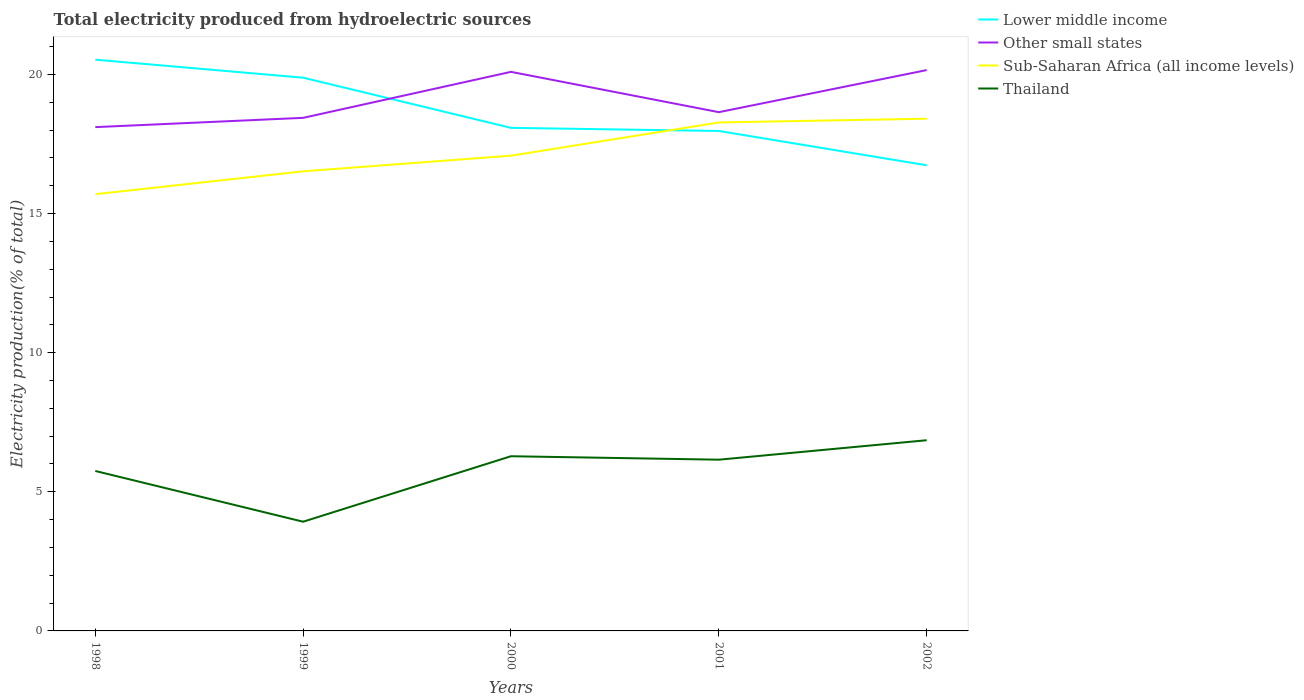How many different coloured lines are there?
Your answer should be very brief. 4. Across all years, what is the maximum total electricity produced in Sub-Saharan Africa (all income levels)?
Ensure brevity in your answer.  15.7. What is the total total electricity produced in Lower middle income in the graph?
Offer a terse response. 2.56. What is the difference between the highest and the second highest total electricity produced in Lower middle income?
Provide a succinct answer. 3.8. How many lines are there?
Keep it short and to the point. 4. What is the difference between two consecutive major ticks on the Y-axis?
Provide a succinct answer. 5. Are the values on the major ticks of Y-axis written in scientific E-notation?
Provide a short and direct response. No. Does the graph contain any zero values?
Give a very brief answer. No. Does the graph contain grids?
Your response must be concise. No. How many legend labels are there?
Keep it short and to the point. 4. What is the title of the graph?
Your answer should be very brief. Total electricity produced from hydroelectric sources. What is the Electricity production(% of total) in Lower middle income in 1998?
Keep it short and to the point. 20.53. What is the Electricity production(% of total) of Other small states in 1998?
Provide a short and direct response. 18.11. What is the Electricity production(% of total) in Sub-Saharan Africa (all income levels) in 1998?
Your response must be concise. 15.7. What is the Electricity production(% of total) of Thailand in 1998?
Keep it short and to the point. 5.75. What is the Electricity production(% of total) of Lower middle income in 1999?
Make the answer very short. 19.88. What is the Electricity production(% of total) of Other small states in 1999?
Offer a very short reply. 18.44. What is the Electricity production(% of total) in Sub-Saharan Africa (all income levels) in 1999?
Offer a very short reply. 16.52. What is the Electricity production(% of total) of Thailand in 1999?
Offer a terse response. 3.92. What is the Electricity production(% of total) in Lower middle income in 2000?
Give a very brief answer. 18.08. What is the Electricity production(% of total) of Other small states in 2000?
Keep it short and to the point. 20.09. What is the Electricity production(% of total) in Sub-Saharan Africa (all income levels) in 2000?
Offer a very short reply. 17.08. What is the Electricity production(% of total) in Thailand in 2000?
Make the answer very short. 6.28. What is the Electricity production(% of total) of Lower middle income in 2001?
Provide a short and direct response. 17.97. What is the Electricity production(% of total) in Other small states in 2001?
Your answer should be compact. 18.64. What is the Electricity production(% of total) of Sub-Saharan Africa (all income levels) in 2001?
Make the answer very short. 18.27. What is the Electricity production(% of total) in Thailand in 2001?
Offer a terse response. 6.15. What is the Electricity production(% of total) in Lower middle income in 2002?
Give a very brief answer. 16.73. What is the Electricity production(% of total) of Other small states in 2002?
Your answer should be very brief. 20.16. What is the Electricity production(% of total) of Sub-Saharan Africa (all income levels) in 2002?
Keep it short and to the point. 18.41. What is the Electricity production(% of total) in Thailand in 2002?
Give a very brief answer. 6.85. Across all years, what is the maximum Electricity production(% of total) in Lower middle income?
Provide a short and direct response. 20.53. Across all years, what is the maximum Electricity production(% of total) of Other small states?
Offer a very short reply. 20.16. Across all years, what is the maximum Electricity production(% of total) in Sub-Saharan Africa (all income levels)?
Make the answer very short. 18.41. Across all years, what is the maximum Electricity production(% of total) of Thailand?
Ensure brevity in your answer.  6.85. Across all years, what is the minimum Electricity production(% of total) in Lower middle income?
Provide a succinct answer. 16.73. Across all years, what is the minimum Electricity production(% of total) in Other small states?
Give a very brief answer. 18.11. Across all years, what is the minimum Electricity production(% of total) of Sub-Saharan Africa (all income levels)?
Provide a short and direct response. 15.7. Across all years, what is the minimum Electricity production(% of total) of Thailand?
Offer a very short reply. 3.92. What is the total Electricity production(% of total) of Lower middle income in the graph?
Ensure brevity in your answer.  93.2. What is the total Electricity production(% of total) of Other small states in the graph?
Make the answer very short. 95.44. What is the total Electricity production(% of total) of Sub-Saharan Africa (all income levels) in the graph?
Ensure brevity in your answer.  85.98. What is the total Electricity production(% of total) in Thailand in the graph?
Your response must be concise. 28.96. What is the difference between the Electricity production(% of total) of Lower middle income in 1998 and that in 1999?
Ensure brevity in your answer.  0.65. What is the difference between the Electricity production(% of total) in Other small states in 1998 and that in 1999?
Your response must be concise. -0.33. What is the difference between the Electricity production(% of total) of Sub-Saharan Africa (all income levels) in 1998 and that in 1999?
Provide a succinct answer. -0.82. What is the difference between the Electricity production(% of total) in Thailand in 1998 and that in 1999?
Your answer should be compact. 1.82. What is the difference between the Electricity production(% of total) in Lower middle income in 1998 and that in 2000?
Offer a terse response. 2.45. What is the difference between the Electricity production(% of total) in Other small states in 1998 and that in 2000?
Ensure brevity in your answer.  -1.99. What is the difference between the Electricity production(% of total) of Sub-Saharan Africa (all income levels) in 1998 and that in 2000?
Offer a terse response. -1.38. What is the difference between the Electricity production(% of total) in Thailand in 1998 and that in 2000?
Make the answer very short. -0.53. What is the difference between the Electricity production(% of total) of Lower middle income in 1998 and that in 2001?
Offer a terse response. 2.56. What is the difference between the Electricity production(% of total) in Other small states in 1998 and that in 2001?
Provide a short and direct response. -0.54. What is the difference between the Electricity production(% of total) of Sub-Saharan Africa (all income levels) in 1998 and that in 2001?
Make the answer very short. -2.58. What is the difference between the Electricity production(% of total) of Thailand in 1998 and that in 2001?
Make the answer very short. -0.41. What is the difference between the Electricity production(% of total) of Lower middle income in 1998 and that in 2002?
Your answer should be compact. 3.8. What is the difference between the Electricity production(% of total) in Other small states in 1998 and that in 2002?
Make the answer very short. -2.05. What is the difference between the Electricity production(% of total) in Sub-Saharan Africa (all income levels) in 1998 and that in 2002?
Make the answer very short. -2.71. What is the difference between the Electricity production(% of total) of Thailand in 1998 and that in 2002?
Your answer should be compact. -1.1. What is the difference between the Electricity production(% of total) in Lower middle income in 1999 and that in 2000?
Your answer should be compact. 1.8. What is the difference between the Electricity production(% of total) of Other small states in 1999 and that in 2000?
Offer a very short reply. -1.65. What is the difference between the Electricity production(% of total) of Sub-Saharan Africa (all income levels) in 1999 and that in 2000?
Ensure brevity in your answer.  -0.56. What is the difference between the Electricity production(% of total) in Thailand in 1999 and that in 2000?
Keep it short and to the point. -2.35. What is the difference between the Electricity production(% of total) in Lower middle income in 1999 and that in 2001?
Give a very brief answer. 1.91. What is the difference between the Electricity production(% of total) of Other small states in 1999 and that in 2001?
Give a very brief answer. -0.2. What is the difference between the Electricity production(% of total) of Sub-Saharan Africa (all income levels) in 1999 and that in 2001?
Offer a terse response. -1.76. What is the difference between the Electricity production(% of total) in Thailand in 1999 and that in 2001?
Provide a short and direct response. -2.23. What is the difference between the Electricity production(% of total) of Lower middle income in 1999 and that in 2002?
Ensure brevity in your answer.  3.15. What is the difference between the Electricity production(% of total) of Other small states in 1999 and that in 2002?
Give a very brief answer. -1.72. What is the difference between the Electricity production(% of total) in Sub-Saharan Africa (all income levels) in 1999 and that in 2002?
Keep it short and to the point. -1.89. What is the difference between the Electricity production(% of total) of Thailand in 1999 and that in 2002?
Keep it short and to the point. -2.93. What is the difference between the Electricity production(% of total) in Lower middle income in 2000 and that in 2001?
Offer a terse response. 0.11. What is the difference between the Electricity production(% of total) in Other small states in 2000 and that in 2001?
Keep it short and to the point. 1.45. What is the difference between the Electricity production(% of total) in Sub-Saharan Africa (all income levels) in 2000 and that in 2001?
Your response must be concise. -1.19. What is the difference between the Electricity production(% of total) of Thailand in 2000 and that in 2001?
Offer a very short reply. 0.12. What is the difference between the Electricity production(% of total) in Lower middle income in 2000 and that in 2002?
Give a very brief answer. 1.35. What is the difference between the Electricity production(% of total) in Other small states in 2000 and that in 2002?
Your answer should be very brief. -0.06. What is the difference between the Electricity production(% of total) in Sub-Saharan Africa (all income levels) in 2000 and that in 2002?
Offer a terse response. -1.33. What is the difference between the Electricity production(% of total) in Thailand in 2000 and that in 2002?
Offer a terse response. -0.57. What is the difference between the Electricity production(% of total) of Lower middle income in 2001 and that in 2002?
Your response must be concise. 1.23. What is the difference between the Electricity production(% of total) of Other small states in 2001 and that in 2002?
Provide a succinct answer. -1.51. What is the difference between the Electricity production(% of total) in Sub-Saharan Africa (all income levels) in 2001 and that in 2002?
Provide a short and direct response. -0.13. What is the difference between the Electricity production(% of total) in Thailand in 2001 and that in 2002?
Provide a succinct answer. -0.7. What is the difference between the Electricity production(% of total) in Lower middle income in 1998 and the Electricity production(% of total) in Other small states in 1999?
Your answer should be compact. 2.09. What is the difference between the Electricity production(% of total) in Lower middle income in 1998 and the Electricity production(% of total) in Sub-Saharan Africa (all income levels) in 1999?
Keep it short and to the point. 4.01. What is the difference between the Electricity production(% of total) in Lower middle income in 1998 and the Electricity production(% of total) in Thailand in 1999?
Give a very brief answer. 16.61. What is the difference between the Electricity production(% of total) in Other small states in 1998 and the Electricity production(% of total) in Sub-Saharan Africa (all income levels) in 1999?
Provide a succinct answer. 1.59. What is the difference between the Electricity production(% of total) in Other small states in 1998 and the Electricity production(% of total) in Thailand in 1999?
Offer a terse response. 14.18. What is the difference between the Electricity production(% of total) in Sub-Saharan Africa (all income levels) in 1998 and the Electricity production(% of total) in Thailand in 1999?
Offer a terse response. 11.77. What is the difference between the Electricity production(% of total) of Lower middle income in 1998 and the Electricity production(% of total) of Other small states in 2000?
Provide a short and direct response. 0.44. What is the difference between the Electricity production(% of total) of Lower middle income in 1998 and the Electricity production(% of total) of Sub-Saharan Africa (all income levels) in 2000?
Keep it short and to the point. 3.45. What is the difference between the Electricity production(% of total) of Lower middle income in 1998 and the Electricity production(% of total) of Thailand in 2000?
Give a very brief answer. 14.25. What is the difference between the Electricity production(% of total) in Other small states in 1998 and the Electricity production(% of total) in Sub-Saharan Africa (all income levels) in 2000?
Give a very brief answer. 1.03. What is the difference between the Electricity production(% of total) of Other small states in 1998 and the Electricity production(% of total) of Thailand in 2000?
Your answer should be compact. 11.83. What is the difference between the Electricity production(% of total) of Sub-Saharan Africa (all income levels) in 1998 and the Electricity production(% of total) of Thailand in 2000?
Your response must be concise. 9.42. What is the difference between the Electricity production(% of total) in Lower middle income in 1998 and the Electricity production(% of total) in Other small states in 2001?
Make the answer very short. 1.89. What is the difference between the Electricity production(% of total) in Lower middle income in 1998 and the Electricity production(% of total) in Sub-Saharan Africa (all income levels) in 2001?
Make the answer very short. 2.26. What is the difference between the Electricity production(% of total) of Lower middle income in 1998 and the Electricity production(% of total) of Thailand in 2001?
Your answer should be very brief. 14.38. What is the difference between the Electricity production(% of total) of Other small states in 1998 and the Electricity production(% of total) of Sub-Saharan Africa (all income levels) in 2001?
Give a very brief answer. -0.17. What is the difference between the Electricity production(% of total) of Other small states in 1998 and the Electricity production(% of total) of Thailand in 2001?
Offer a terse response. 11.95. What is the difference between the Electricity production(% of total) in Sub-Saharan Africa (all income levels) in 1998 and the Electricity production(% of total) in Thailand in 2001?
Your answer should be compact. 9.54. What is the difference between the Electricity production(% of total) of Lower middle income in 1998 and the Electricity production(% of total) of Other small states in 2002?
Provide a short and direct response. 0.37. What is the difference between the Electricity production(% of total) in Lower middle income in 1998 and the Electricity production(% of total) in Sub-Saharan Africa (all income levels) in 2002?
Keep it short and to the point. 2.12. What is the difference between the Electricity production(% of total) in Lower middle income in 1998 and the Electricity production(% of total) in Thailand in 2002?
Keep it short and to the point. 13.68. What is the difference between the Electricity production(% of total) of Other small states in 1998 and the Electricity production(% of total) of Sub-Saharan Africa (all income levels) in 2002?
Give a very brief answer. -0.3. What is the difference between the Electricity production(% of total) in Other small states in 1998 and the Electricity production(% of total) in Thailand in 2002?
Keep it short and to the point. 11.25. What is the difference between the Electricity production(% of total) in Sub-Saharan Africa (all income levels) in 1998 and the Electricity production(% of total) in Thailand in 2002?
Your response must be concise. 8.84. What is the difference between the Electricity production(% of total) of Lower middle income in 1999 and the Electricity production(% of total) of Other small states in 2000?
Make the answer very short. -0.21. What is the difference between the Electricity production(% of total) of Lower middle income in 1999 and the Electricity production(% of total) of Sub-Saharan Africa (all income levels) in 2000?
Ensure brevity in your answer.  2.8. What is the difference between the Electricity production(% of total) in Lower middle income in 1999 and the Electricity production(% of total) in Thailand in 2000?
Your response must be concise. 13.6. What is the difference between the Electricity production(% of total) in Other small states in 1999 and the Electricity production(% of total) in Sub-Saharan Africa (all income levels) in 2000?
Offer a very short reply. 1.36. What is the difference between the Electricity production(% of total) in Other small states in 1999 and the Electricity production(% of total) in Thailand in 2000?
Ensure brevity in your answer.  12.16. What is the difference between the Electricity production(% of total) in Sub-Saharan Africa (all income levels) in 1999 and the Electricity production(% of total) in Thailand in 2000?
Keep it short and to the point. 10.24. What is the difference between the Electricity production(% of total) in Lower middle income in 1999 and the Electricity production(% of total) in Other small states in 2001?
Keep it short and to the point. 1.24. What is the difference between the Electricity production(% of total) in Lower middle income in 1999 and the Electricity production(% of total) in Sub-Saharan Africa (all income levels) in 2001?
Offer a very short reply. 1.61. What is the difference between the Electricity production(% of total) in Lower middle income in 1999 and the Electricity production(% of total) in Thailand in 2001?
Your answer should be compact. 13.73. What is the difference between the Electricity production(% of total) in Other small states in 1999 and the Electricity production(% of total) in Sub-Saharan Africa (all income levels) in 2001?
Your answer should be compact. 0.17. What is the difference between the Electricity production(% of total) of Other small states in 1999 and the Electricity production(% of total) of Thailand in 2001?
Your answer should be compact. 12.29. What is the difference between the Electricity production(% of total) of Sub-Saharan Africa (all income levels) in 1999 and the Electricity production(% of total) of Thailand in 2001?
Provide a short and direct response. 10.36. What is the difference between the Electricity production(% of total) in Lower middle income in 1999 and the Electricity production(% of total) in Other small states in 2002?
Provide a succinct answer. -0.27. What is the difference between the Electricity production(% of total) in Lower middle income in 1999 and the Electricity production(% of total) in Sub-Saharan Africa (all income levels) in 2002?
Make the answer very short. 1.47. What is the difference between the Electricity production(% of total) in Lower middle income in 1999 and the Electricity production(% of total) in Thailand in 2002?
Give a very brief answer. 13.03. What is the difference between the Electricity production(% of total) in Other small states in 1999 and the Electricity production(% of total) in Sub-Saharan Africa (all income levels) in 2002?
Offer a very short reply. 0.03. What is the difference between the Electricity production(% of total) of Other small states in 1999 and the Electricity production(% of total) of Thailand in 2002?
Offer a terse response. 11.59. What is the difference between the Electricity production(% of total) in Sub-Saharan Africa (all income levels) in 1999 and the Electricity production(% of total) in Thailand in 2002?
Keep it short and to the point. 9.67. What is the difference between the Electricity production(% of total) in Lower middle income in 2000 and the Electricity production(% of total) in Other small states in 2001?
Ensure brevity in your answer.  -0.56. What is the difference between the Electricity production(% of total) of Lower middle income in 2000 and the Electricity production(% of total) of Sub-Saharan Africa (all income levels) in 2001?
Ensure brevity in your answer.  -0.19. What is the difference between the Electricity production(% of total) in Lower middle income in 2000 and the Electricity production(% of total) in Thailand in 2001?
Your response must be concise. 11.93. What is the difference between the Electricity production(% of total) of Other small states in 2000 and the Electricity production(% of total) of Sub-Saharan Africa (all income levels) in 2001?
Your answer should be compact. 1.82. What is the difference between the Electricity production(% of total) in Other small states in 2000 and the Electricity production(% of total) in Thailand in 2001?
Your answer should be compact. 13.94. What is the difference between the Electricity production(% of total) of Sub-Saharan Africa (all income levels) in 2000 and the Electricity production(% of total) of Thailand in 2001?
Your answer should be very brief. 10.93. What is the difference between the Electricity production(% of total) of Lower middle income in 2000 and the Electricity production(% of total) of Other small states in 2002?
Keep it short and to the point. -2.08. What is the difference between the Electricity production(% of total) of Lower middle income in 2000 and the Electricity production(% of total) of Sub-Saharan Africa (all income levels) in 2002?
Make the answer very short. -0.33. What is the difference between the Electricity production(% of total) in Lower middle income in 2000 and the Electricity production(% of total) in Thailand in 2002?
Give a very brief answer. 11.23. What is the difference between the Electricity production(% of total) in Other small states in 2000 and the Electricity production(% of total) in Sub-Saharan Africa (all income levels) in 2002?
Keep it short and to the point. 1.68. What is the difference between the Electricity production(% of total) of Other small states in 2000 and the Electricity production(% of total) of Thailand in 2002?
Provide a succinct answer. 13.24. What is the difference between the Electricity production(% of total) in Sub-Saharan Africa (all income levels) in 2000 and the Electricity production(% of total) in Thailand in 2002?
Provide a short and direct response. 10.23. What is the difference between the Electricity production(% of total) of Lower middle income in 2001 and the Electricity production(% of total) of Other small states in 2002?
Your response must be concise. -2.19. What is the difference between the Electricity production(% of total) in Lower middle income in 2001 and the Electricity production(% of total) in Sub-Saharan Africa (all income levels) in 2002?
Your answer should be compact. -0.44. What is the difference between the Electricity production(% of total) of Lower middle income in 2001 and the Electricity production(% of total) of Thailand in 2002?
Make the answer very short. 11.11. What is the difference between the Electricity production(% of total) of Other small states in 2001 and the Electricity production(% of total) of Sub-Saharan Africa (all income levels) in 2002?
Ensure brevity in your answer.  0.23. What is the difference between the Electricity production(% of total) of Other small states in 2001 and the Electricity production(% of total) of Thailand in 2002?
Provide a succinct answer. 11.79. What is the difference between the Electricity production(% of total) in Sub-Saharan Africa (all income levels) in 2001 and the Electricity production(% of total) in Thailand in 2002?
Keep it short and to the point. 11.42. What is the average Electricity production(% of total) in Lower middle income per year?
Your answer should be very brief. 18.64. What is the average Electricity production(% of total) in Other small states per year?
Make the answer very short. 19.09. What is the average Electricity production(% of total) in Sub-Saharan Africa (all income levels) per year?
Ensure brevity in your answer.  17.2. What is the average Electricity production(% of total) in Thailand per year?
Provide a short and direct response. 5.79. In the year 1998, what is the difference between the Electricity production(% of total) in Lower middle income and Electricity production(% of total) in Other small states?
Your answer should be very brief. 2.42. In the year 1998, what is the difference between the Electricity production(% of total) in Lower middle income and Electricity production(% of total) in Sub-Saharan Africa (all income levels)?
Provide a short and direct response. 4.83. In the year 1998, what is the difference between the Electricity production(% of total) in Lower middle income and Electricity production(% of total) in Thailand?
Offer a terse response. 14.78. In the year 1998, what is the difference between the Electricity production(% of total) of Other small states and Electricity production(% of total) of Sub-Saharan Africa (all income levels)?
Your response must be concise. 2.41. In the year 1998, what is the difference between the Electricity production(% of total) in Other small states and Electricity production(% of total) in Thailand?
Offer a very short reply. 12.36. In the year 1998, what is the difference between the Electricity production(% of total) in Sub-Saharan Africa (all income levels) and Electricity production(% of total) in Thailand?
Your response must be concise. 9.95. In the year 1999, what is the difference between the Electricity production(% of total) in Lower middle income and Electricity production(% of total) in Other small states?
Keep it short and to the point. 1.44. In the year 1999, what is the difference between the Electricity production(% of total) in Lower middle income and Electricity production(% of total) in Sub-Saharan Africa (all income levels)?
Your answer should be compact. 3.36. In the year 1999, what is the difference between the Electricity production(% of total) in Lower middle income and Electricity production(% of total) in Thailand?
Keep it short and to the point. 15.96. In the year 1999, what is the difference between the Electricity production(% of total) in Other small states and Electricity production(% of total) in Sub-Saharan Africa (all income levels)?
Your answer should be compact. 1.92. In the year 1999, what is the difference between the Electricity production(% of total) of Other small states and Electricity production(% of total) of Thailand?
Make the answer very short. 14.52. In the year 1999, what is the difference between the Electricity production(% of total) of Sub-Saharan Africa (all income levels) and Electricity production(% of total) of Thailand?
Your response must be concise. 12.59. In the year 2000, what is the difference between the Electricity production(% of total) in Lower middle income and Electricity production(% of total) in Other small states?
Offer a terse response. -2.01. In the year 2000, what is the difference between the Electricity production(% of total) in Lower middle income and Electricity production(% of total) in Sub-Saharan Africa (all income levels)?
Ensure brevity in your answer.  1. In the year 2000, what is the difference between the Electricity production(% of total) of Lower middle income and Electricity production(% of total) of Thailand?
Ensure brevity in your answer.  11.8. In the year 2000, what is the difference between the Electricity production(% of total) of Other small states and Electricity production(% of total) of Sub-Saharan Africa (all income levels)?
Give a very brief answer. 3.01. In the year 2000, what is the difference between the Electricity production(% of total) in Other small states and Electricity production(% of total) in Thailand?
Offer a very short reply. 13.81. In the year 2000, what is the difference between the Electricity production(% of total) of Sub-Saharan Africa (all income levels) and Electricity production(% of total) of Thailand?
Give a very brief answer. 10.8. In the year 2001, what is the difference between the Electricity production(% of total) of Lower middle income and Electricity production(% of total) of Other small states?
Your answer should be very brief. -0.68. In the year 2001, what is the difference between the Electricity production(% of total) in Lower middle income and Electricity production(% of total) in Sub-Saharan Africa (all income levels)?
Give a very brief answer. -0.31. In the year 2001, what is the difference between the Electricity production(% of total) in Lower middle income and Electricity production(% of total) in Thailand?
Provide a short and direct response. 11.81. In the year 2001, what is the difference between the Electricity production(% of total) of Other small states and Electricity production(% of total) of Sub-Saharan Africa (all income levels)?
Make the answer very short. 0.37. In the year 2001, what is the difference between the Electricity production(% of total) in Other small states and Electricity production(% of total) in Thailand?
Ensure brevity in your answer.  12.49. In the year 2001, what is the difference between the Electricity production(% of total) of Sub-Saharan Africa (all income levels) and Electricity production(% of total) of Thailand?
Your answer should be compact. 12.12. In the year 2002, what is the difference between the Electricity production(% of total) in Lower middle income and Electricity production(% of total) in Other small states?
Offer a very short reply. -3.42. In the year 2002, what is the difference between the Electricity production(% of total) of Lower middle income and Electricity production(% of total) of Sub-Saharan Africa (all income levels)?
Your answer should be very brief. -1.67. In the year 2002, what is the difference between the Electricity production(% of total) in Lower middle income and Electricity production(% of total) in Thailand?
Offer a terse response. 9.88. In the year 2002, what is the difference between the Electricity production(% of total) in Other small states and Electricity production(% of total) in Sub-Saharan Africa (all income levels)?
Your answer should be compact. 1.75. In the year 2002, what is the difference between the Electricity production(% of total) of Other small states and Electricity production(% of total) of Thailand?
Provide a succinct answer. 13.3. In the year 2002, what is the difference between the Electricity production(% of total) of Sub-Saharan Africa (all income levels) and Electricity production(% of total) of Thailand?
Make the answer very short. 11.56. What is the ratio of the Electricity production(% of total) of Lower middle income in 1998 to that in 1999?
Keep it short and to the point. 1.03. What is the ratio of the Electricity production(% of total) in Other small states in 1998 to that in 1999?
Your response must be concise. 0.98. What is the ratio of the Electricity production(% of total) in Sub-Saharan Africa (all income levels) in 1998 to that in 1999?
Your answer should be very brief. 0.95. What is the ratio of the Electricity production(% of total) in Thailand in 1998 to that in 1999?
Make the answer very short. 1.46. What is the ratio of the Electricity production(% of total) in Lower middle income in 1998 to that in 2000?
Your response must be concise. 1.14. What is the ratio of the Electricity production(% of total) in Other small states in 1998 to that in 2000?
Provide a short and direct response. 0.9. What is the ratio of the Electricity production(% of total) in Sub-Saharan Africa (all income levels) in 1998 to that in 2000?
Offer a very short reply. 0.92. What is the ratio of the Electricity production(% of total) in Thailand in 1998 to that in 2000?
Provide a succinct answer. 0.92. What is the ratio of the Electricity production(% of total) in Lower middle income in 1998 to that in 2001?
Provide a succinct answer. 1.14. What is the ratio of the Electricity production(% of total) of Other small states in 1998 to that in 2001?
Your answer should be very brief. 0.97. What is the ratio of the Electricity production(% of total) in Sub-Saharan Africa (all income levels) in 1998 to that in 2001?
Keep it short and to the point. 0.86. What is the ratio of the Electricity production(% of total) of Thailand in 1998 to that in 2001?
Provide a short and direct response. 0.93. What is the ratio of the Electricity production(% of total) of Lower middle income in 1998 to that in 2002?
Give a very brief answer. 1.23. What is the ratio of the Electricity production(% of total) in Other small states in 1998 to that in 2002?
Offer a very short reply. 0.9. What is the ratio of the Electricity production(% of total) of Sub-Saharan Africa (all income levels) in 1998 to that in 2002?
Make the answer very short. 0.85. What is the ratio of the Electricity production(% of total) in Thailand in 1998 to that in 2002?
Give a very brief answer. 0.84. What is the ratio of the Electricity production(% of total) of Lower middle income in 1999 to that in 2000?
Keep it short and to the point. 1.1. What is the ratio of the Electricity production(% of total) of Other small states in 1999 to that in 2000?
Provide a succinct answer. 0.92. What is the ratio of the Electricity production(% of total) of Sub-Saharan Africa (all income levels) in 1999 to that in 2000?
Your response must be concise. 0.97. What is the ratio of the Electricity production(% of total) of Thailand in 1999 to that in 2000?
Offer a terse response. 0.63. What is the ratio of the Electricity production(% of total) of Lower middle income in 1999 to that in 2001?
Offer a very short reply. 1.11. What is the ratio of the Electricity production(% of total) of Sub-Saharan Africa (all income levels) in 1999 to that in 2001?
Provide a short and direct response. 0.9. What is the ratio of the Electricity production(% of total) of Thailand in 1999 to that in 2001?
Provide a succinct answer. 0.64. What is the ratio of the Electricity production(% of total) in Lower middle income in 1999 to that in 2002?
Give a very brief answer. 1.19. What is the ratio of the Electricity production(% of total) in Other small states in 1999 to that in 2002?
Give a very brief answer. 0.91. What is the ratio of the Electricity production(% of total) of Sub-Saharan Africa (all income levels) in 1999 to that in 2002?
Ensure brevity in your answer.  0.9. What is the ratio of the Electricity production(% of total) in Thailand in 1999 to that in 2002?
Give a very brief answer. 0.57. What is the ratio of the Electricity production(% of total) in Lower middle income in 2000 to that in 2001?
Provide a short and direct response. 1.01. What is the ratio of the Electricity production(% of total) of Other small states in 2000 to that in 2001?
Make the answer very short. 1.08. What is the ratio of the Electricity production(% of total) of Sub-Saharan Africa (all income levels) in 2000 to that in 2001?
Make the answer very short. 0.93. What is the ratio of the Electricity production(% of total) in Thailand in 2000 to that in 2001?
Offer a terse response. 1.02. What is the ratio of the Electricity production(% of total) of Lower middle income in 2000 to that in 2002?
Give a very brief answer. 1.08. What is the ratio of the Electricity production(% of total) in Sub-Saharan Africa (all income levels) in 2000 to that in 2002?
Keep it short and to the point. 0.93. What is the ratio of the Electricity production(% of total) in Thailand in 2000 to that in 2002?
Ensure brevity in your answer.  0.92. What is the ratio of the Electricity production(% of total) of Lower middle income in 2001 to that in 2002?
Provide a short and direct response. 1.07. What is the ratio of the Electricity production(% of total) in Other small states in 2001 to that in 2002?
Keep it short and to the point. 0.93. What is the ratio of the Electricity production(% of total) of Sub-Saharan Africa (all income levels) in 2001 to that in 2002?
Provide a short and direct response. 0.99. What is the ratio of the Electricity production(% of total) of Thailand in 2001 to that in 2002?
Your answer should be very brief. 0.9. What is the difference between the highest and the second highest Electricity production(% of total) of Lower middle income?
Provide a short and direct response. 0.65. What is the difference between the highest and the second highest Electricity production(% of total) of Other small states?
Your answer should be compact. 0.06. What is the difference between the highest and the second highest Electricity production(% of total) in Sub-Saharan Africa (all income levels)?
Ensure brevity in your answer.  0.13. What is the difference between the highest and the second highest Electricity production(% of total) in Thailand?
Provide a succinct answer. 0.57. What is the difference between the highest and the lowest Electricity production(% of total) in Lower middle income?
Your response must be concise. 3.8. What is the difference between the highest and the lowest Electricity production(% of total) of Other small states?
Offer a very short reply. 2.05. What is the difference between the highest and the lowest Electricity production(% of total) of Sub-Saharan Africa (all income levels)?
Provide a succinct answer. 2.71. What is the difference between the highest and the lowest Electricity production(% of total) in Thailand?
Give a very brief answer. 2.93. 